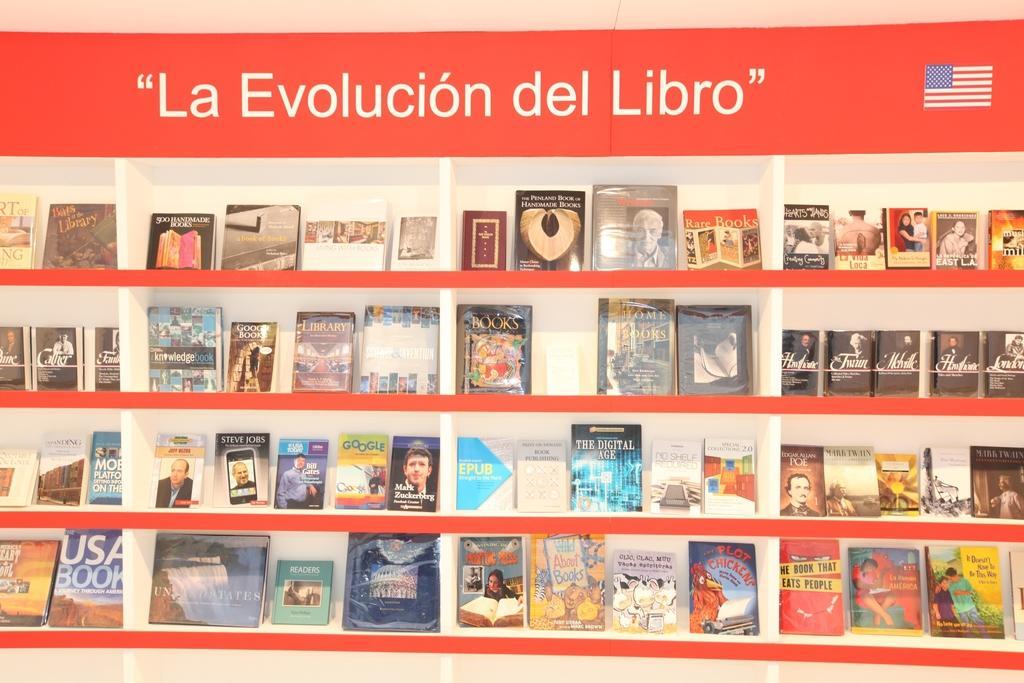Could you give a brief overview of what you see in this image? In this image we can see a group of books which are placed in an order in the shelves. On the top of the image we can see some text and the picture of a flag. 